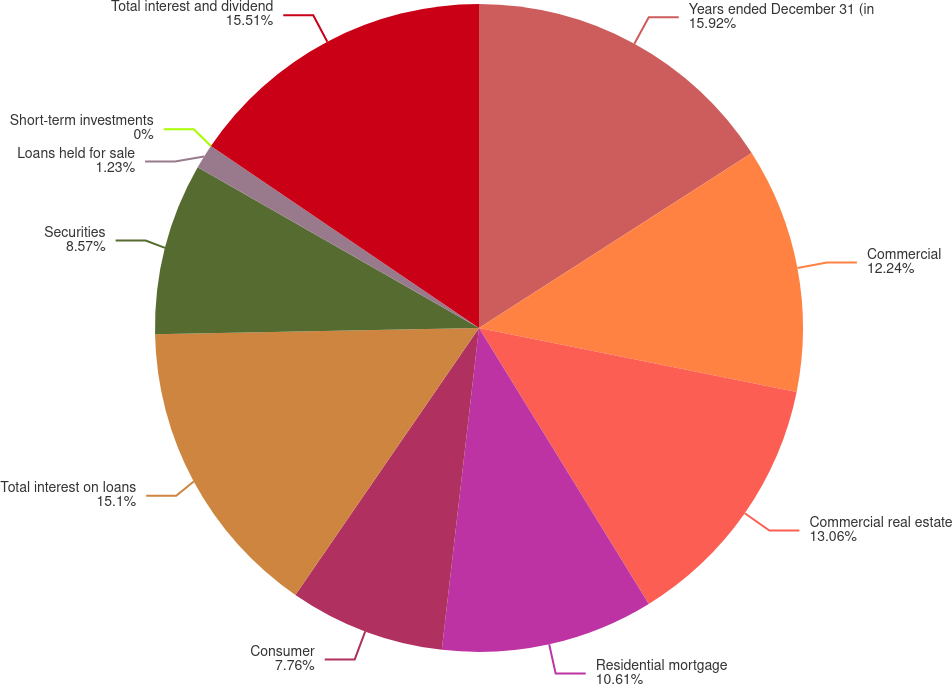Convert chart to OTSL. <chart><loc_0><loc_0><loc_500><loc_500><pie_chart><fcel>Years ended December 31 (in<fcel>Commercial<fcel>Commercial real estate<fcel>Residential mortgage<fcel>Consumer<fcel>Total interest on loans<fcel>Securities<fcel>Loans held for sale<fcel>Short-term investments<fcel>Total interest and dividend<nl><fcel>15.92%<fcel>12.24%<fcel>13.06%<fcel>10.61%<fcel>7.76%<fcel>15.1%<fcel>8.57%<fcel>1.23%<fcel>0.0%<fcel>15.51%<nl></chart> 